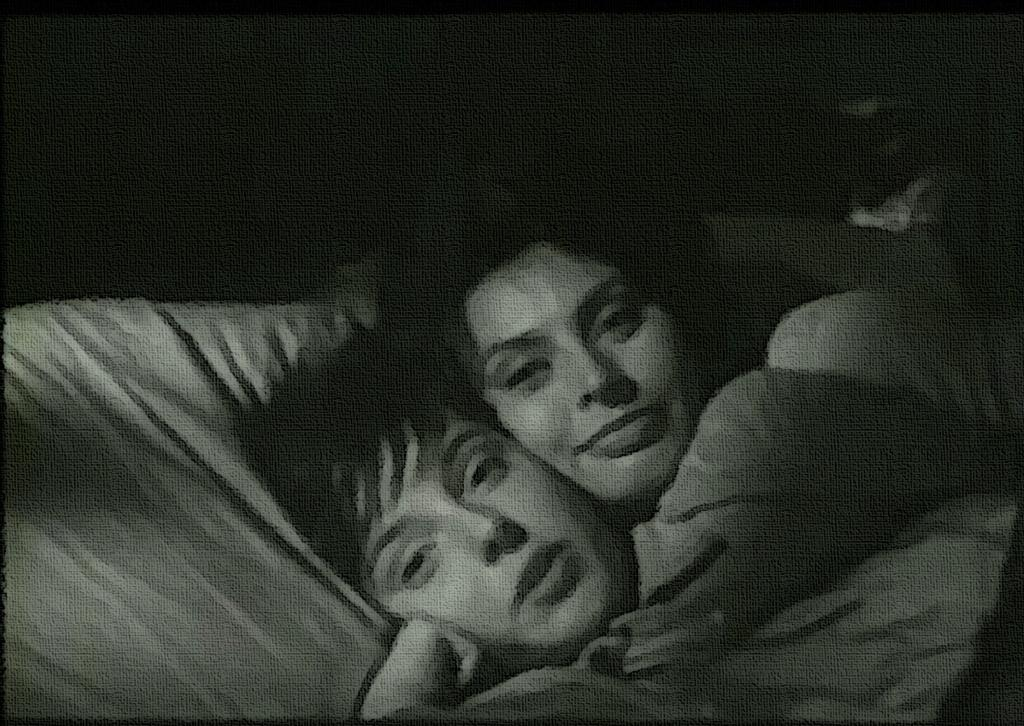What is the color scheme of the image? The image is black and white. What can be seen on the bed in the image? There are people lying on the bed in the image. How would you describe the background of the image? The background of the image is dark. What type of chair is present in the image? There is no chair present in the image. What time of day is it in the image? The time of day cannot be determined from the image, as it is black and white and does not provide any context about the time. 